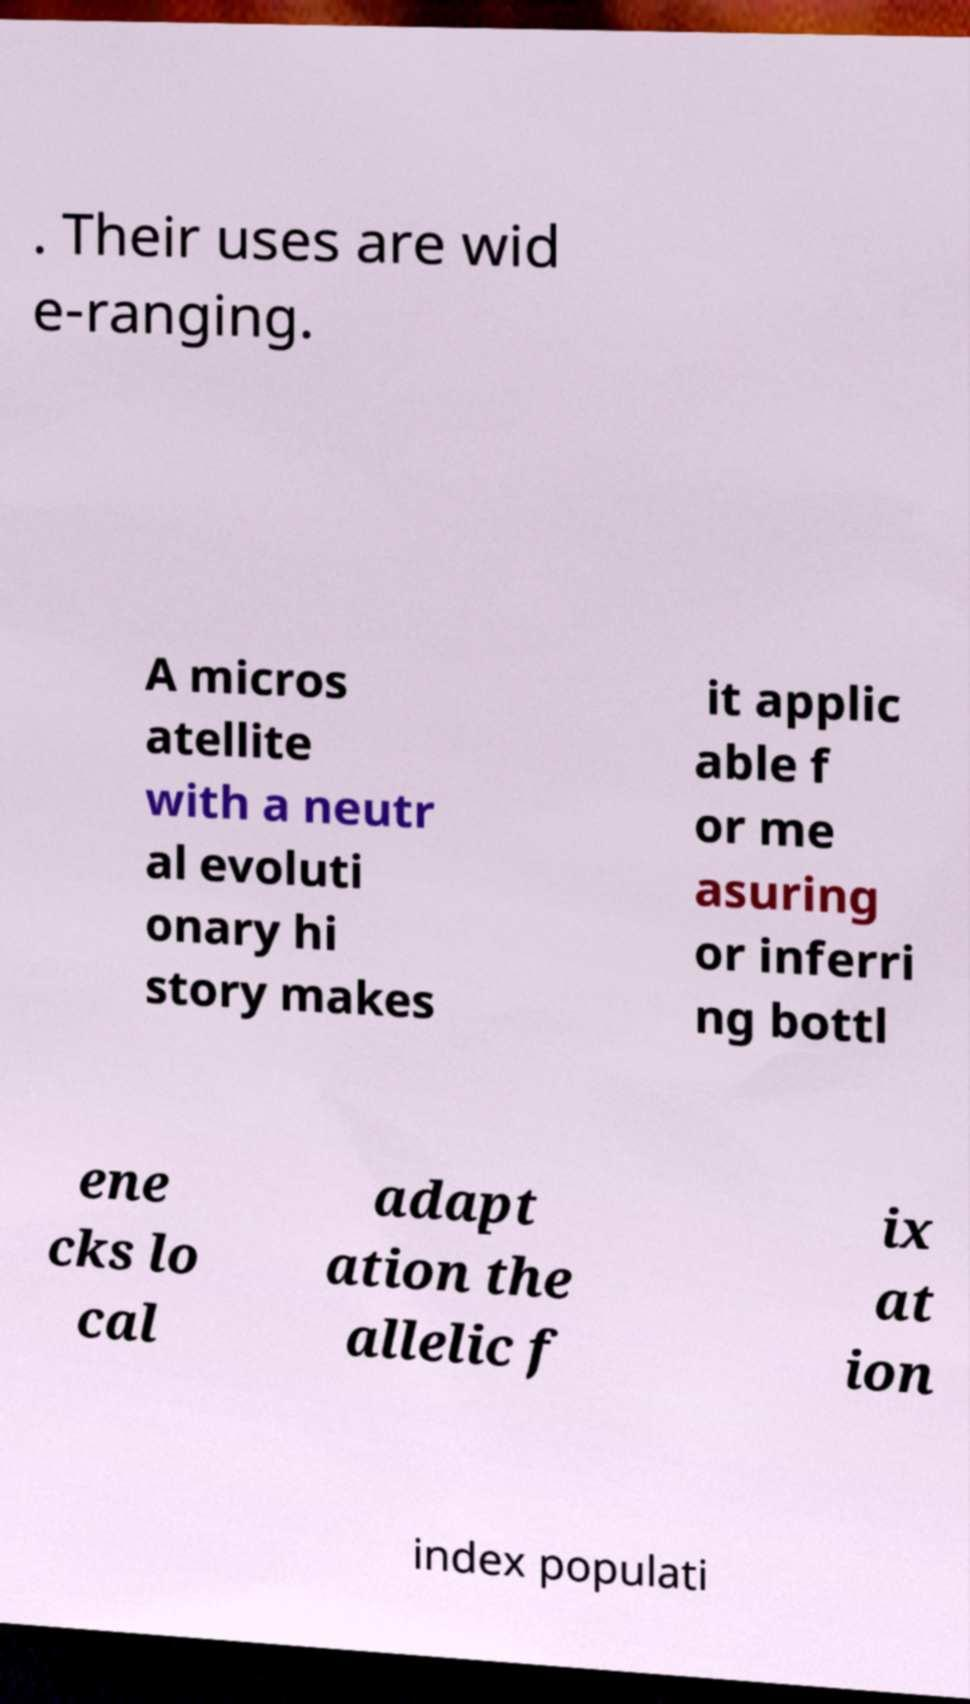Please identify and transcribe the text found in this image. . Their uses are wid e-ranging. A micros atellite with a neutr al evoluti onary hi story makes it applic able f or me asuring or inferri ng bottl ene cks lo cal adapt ation the allelic f ix at ion index populati 